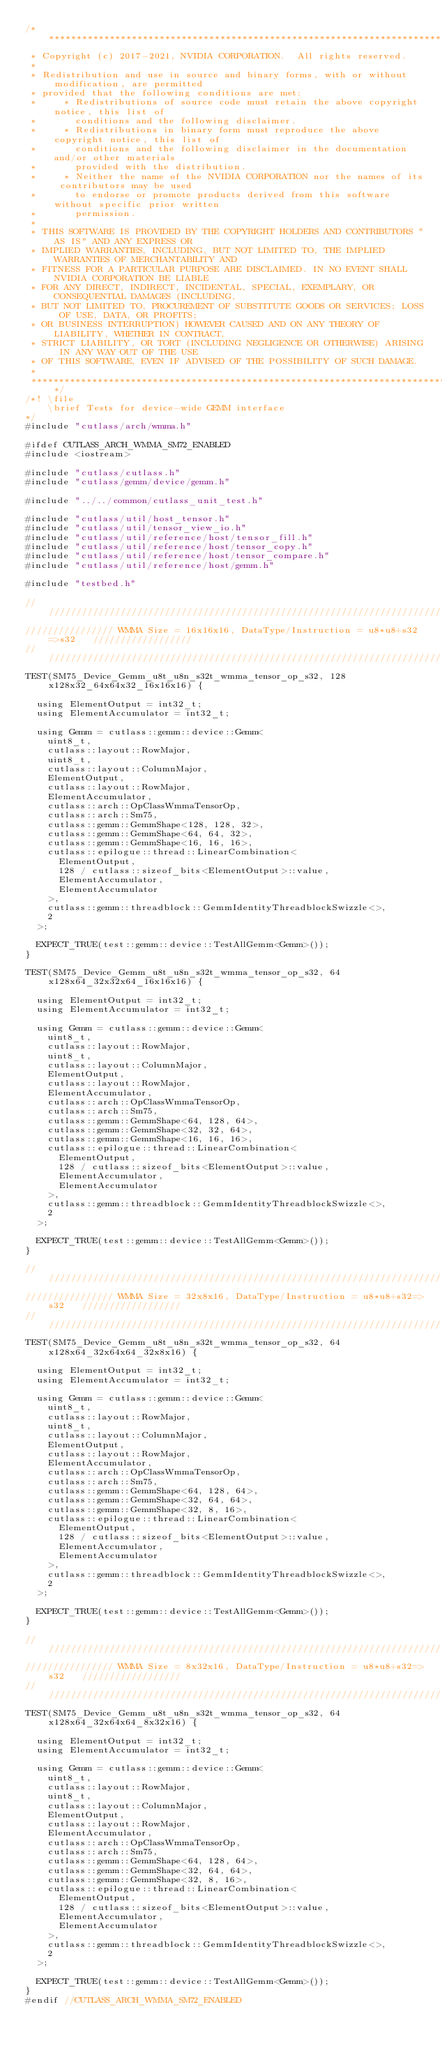Convert code to text. <code><loc_0><loc_0><loc_500><loc_500><_Cuda_>/***************************************************************************************************
 * Copyright (c) 2017-2021, NVIDIA CORPORATION.  All rights reserved.
 *
 * Redistribution and use in source and binary forms, with or without modification, are permitted
 * provided that the following conditions are met:
 *     * Redistributions of source code must retain the above copyright notice, this list of
 *       conditions and the following disclaimer.
 *     * Redistributions in binary form must reproduce the above copyright notice, this list of
 *       conditions and the following disclaimer in the documentation and/or other materials
 *       provided with the distribution.
 *     * Neither the name of the NVIDIA CORPORATION nor the names of its contributors may be used
 *       to endorse or promote products derived from this software without specific prior written
 *       permission.
 *
 * THIS SOFTWARE IS PROVIDED BY THE COPYRIGHT HOLDERS AND CONTRIBUTORS "AS IS" AND ANY EXPRESS OR
 * IMPLIED WARRANTIES, INCLUDING, BUT NOT LIMITED TO, THE IMPLIED WARRANTIES OF MERCHANTABILITY AND
 * FITNESS FOR A PARTICULAR PURPOSE ARE DISCLAIMED. IN NO EVENT SHALL NVIDIA CORPORATION BE LIABLE
 * FOR ANY DIRECT, INDIRECT, INCIDENTAL, SPECIAL, EXEMPLARY, OR CONSEQUENTIAL DAMAGES (INCLUDING,
 * BUT NOT LIMITED TO, PROCUREMENT OF SUBSTITUTE GOODS OR SERVICES; LOSS OF USE, DATA, OR PROFITS;
 * OR BUSINESS INTERRUPTION) HOWEVER CAUSED AND ON ANY THEORY OF LIABILITY, WHETHER IN CONTRACT,
 * STRICT LIABILITY, OR TORT (INCLUDING NEGLIGENCE OR OTHERWISE) ARISING IN ANY WAY OUT OF THE USE
 * OF THIS SOFTWARE, EVEN IF ADVISED OF THE POSSIBILITY OF SUCH DAMAGE.
 *
 **************************************************************************************************/
/*! \file
    \brief Tests for device-wide GEMM interface
*/
#include "cutlass/arch/wmma.h"

#ifdef CUTLASS_ARCH_WMMA_SM72_ENABLED
#include <iostream>

#include "cutlass/cutlass.h"
#include "cutlass/gemm/device/gemm.h"

#include "../../common/cutlass_unit_test.h"

#include "cutlass/util/host_tensor.h"
#include "cutlass/util/tensor_view_io.h"
#include "cutlass/util/reference/host/tensor_fill.h"
#include "cutlass/util/reference/host/tensor_copy.h"
#include "cutlass/util/reference/host/tensor_compare.h"
#include "cutlass/util/reference/host/gemm.h"

#include "testbed.h"

/////////////////////////////////////////////////////////////////////////////////////////////////
//////////////// WMMA Size = 16x16x16, DataType/Instruction = u8*u8+s32=>s32   //////////////////
/////////////////////////////////////////////////////////////////////////////////////////////////    
TEST(SM75_Device_Gemm_u8t_u8n_s32t_wmma_tensor_op_s32, 128x128x32_64x64x32_16x16x16) {

  using ElementOutput = int32_t;
  using ElementAccumulator = int32_t;

  using Gemm = cutlass::gemm::device::Gemm<
    uint8_t,
    cutlass::layout::RowMajor,
    uint8_t,
    cutlass::layout::ColumnMajor,
    ElementOutput,
    cutlass::layout::RowMajor,
    ElementAccumulator,
    cutlass::arch::OpClassWmmaTensorOp,
    cutlass::arch::Sm75,
    cutlass::gemm::GemmShape<128, 128, 32>,
    cutlass::gemm::GemmShape<64, 64, 32>,
    cutlass::gemm::GemmShape<16, 16, 16>,
    cutlass::epilogue::thread::LinearCombination<
      ElementOutput,
      128 / cutlass::sizeof_bits<ElementOutput>::value,
      ElementAccumulator,
      ElementAccumulator
    >,
    cutlass::gemm::threadblock::GemmIdentityThreadblockSwizzle<>,
    2
  >;

  EXPECT_TRUE(test::gemm::device::TestAllGemm<Gemm>());
}

TEST(SM75_Device_Gemm_u8t_u8n_s32t_wmma_tensor_op_s32, 64x128x64_32x32x64_16x16x16) {

  using ElementOutput = int32_t;
  using ElementAccumulator = int32_t;

  using Gemm = cutlass::gemm::device::Gemm<
    uint8_t,
    cutlass::layout::RowMajor,
    uint8_t,
    cutlass::layout::ColumnMajor,
    ElementOutput,
    cutlass::layout::RowMajor,
    ElementAccumulator,
    cutlass::arch::OpClassWmmaTensorOp,
    cutlass::arch::Sm75,
    cutlass::gemm::GemmShape<64, 128, 64>,
    cutlass::gemm::GemmShape<32, 32, 64>,
    cutlass::gemm::GemmShape<16, 16, 16>,
    cutlass::epilogue::thread::LinearCombination<
      ElementOutput,
      128 / cutlass::sizeof_bits<ElementOutput>::value,
      ElementAccumulator,
      ElementAccumulator
    >,
    cutlass::gemm::threadblock::GemmIdentityThreadblockSwizzle<>,
    2
  >;

  EXPECT_TRUE(test::gemm::device::TestAllGemm<Gemm>());
}

/////////////////////////////////////////////////////////////////////////////////////////////////
//////////////// WMMA Size = 32x8x16, DataType/Instruction = u8*u8+s32=>s32   //////////////////
///////////////////////////////////////////////////////////////////////////////////////////////// 
TEST(SM75_Device_Gemm_u8t_u8n_s32t_wmma_tensor_op_s32, 64x128x64_32x64x64_32x8x16) {

  using ElementOutput = int32_t;
  using ElementAccumulator = int32_t;

  using Gemm = cutlass::gemm::device::Gemm<
    uint8_t,
    cutlass::layout::RowMajor,
    uint8_t,
    cutlass::layout::ColumnMajor,
    ElementOutput,
    cutlass::layout::RowMajor,
    ElementAccumulator,
    cutlass::arch::OpClassWmmaTensorOp,
    cutlass::arch::Sm75,
    cutlass::gemm::GemmShape<64, 128, 64>,
    cutlass::gemm::GemmShape<32, 64, 64>,
    cutlass::gemm::GemmShape<32, 8, 16>,
    cutlass::epilogue::thread::LinearCombination<
      ElementOutput,
      128 / cutlass::sizeof_bits<ElementOutput>::value,
      ElementAccumulator,
      ElementAccumulator
    >,
    cutlass::gemm::threadblock::GemmIdentityThreadblockSwizzle<>,
    2
  >;

  EXPECT_TRUE(test::gemm::device::TestAllGemm<Gemm>());
}

/////////////////////////////////////////////////////////////////////////////////////////////////
//////////////// WMMA Size = 8x32x16, DataType/Instruction = u8*u8+s32=>s32   //////////////////
///////////////////////////////////////////////////////////////////////////////////////////////// 
TEST(SM75_Device_Gemm_u8t_u8n_s32t_wmma_tensor_op_s32, 64x128x64_32x64x64_8x32x16) {

  using ElementOutput = int32_t;
  using ElementAccumulator = int32_t;

  using Gemm = cutlass::gemm::device::Gemm<
    uint8_t,
    cutlass::layout::RowMajor,
    uint8_t,
    cutlass::layout::ColumnMajor,
    ElementOutput,
    cutlass::layout::RowMajor,
    ElementAccumulator,
    cutlass::arch::OpClassWmmaTensorOp,
    cutlass::arch::Sm75,
    cutlass::gemm::GemmShape<64, 128, 64>,
    cutlass::gemm::GemmShape<32, 64, 64>,
    cutlass::gemm::GemmShape<32, 8, 16>,
    cutlass::epilogue::thread::LinearCombination<
      ElementOutput,
      128 / cutlass::sizeof_bits<ElementOutput>::value,
      ElementAccumulator,
      ElementAccumulator
    >,
    cutlass::gemm::threadblock::GemmIdentityThreadblockSwizzle<>,
    2
  >;

  EXPECT_TRUE(test::gemm::device::TestAllGemm<Gemm>());
}
#endif //CUTLASS_ARCH_WMMA_SM72_ENABLED
</code> 